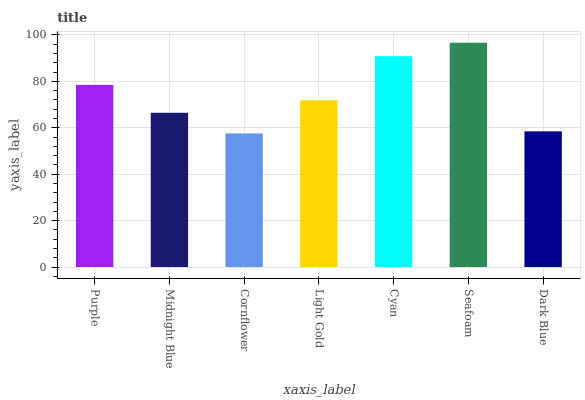Is Midnight Blue the minimum?
Answer yes or no. No. Is Midnight Blue the maximum?
Answer yes or no. No. Is Purple greater than Midnight Blue?
Answer yes or no. Yes. Is Midnight Blue less than Purple?
Answer yes or no. Yes. Is Midnight Blue greater than Purple?
Answer yes or no. No. Is Purple less than Midnight Blue?
Answer yes or no. No. Is Light Gold the high median?
Answer yes or no. Yes. Is Light Gold the low median?
Answer yes or no. Yes. Is Cyan the high median?
Answer yes or no. No. Is Cyan the low median?
Answer yes or no. No. 